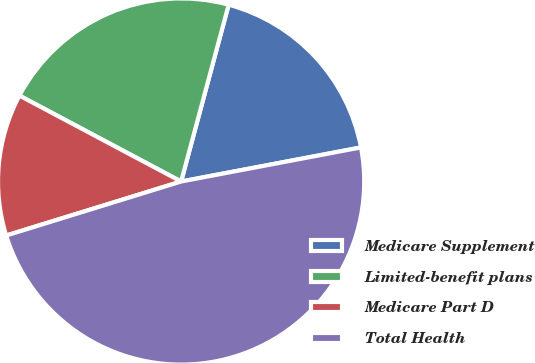<chart> <loc_0><loc_0><loc_500><loc_500><pie_chart><fcel>Medicare Supplement<fcel>Limited-benefit plans<fcel>Medicare Part D<fcel>Total Health<nl><fcel>17.84%<fcel>21.41%<fcel>12.54%<fcel>48.22%<nl></chart> 